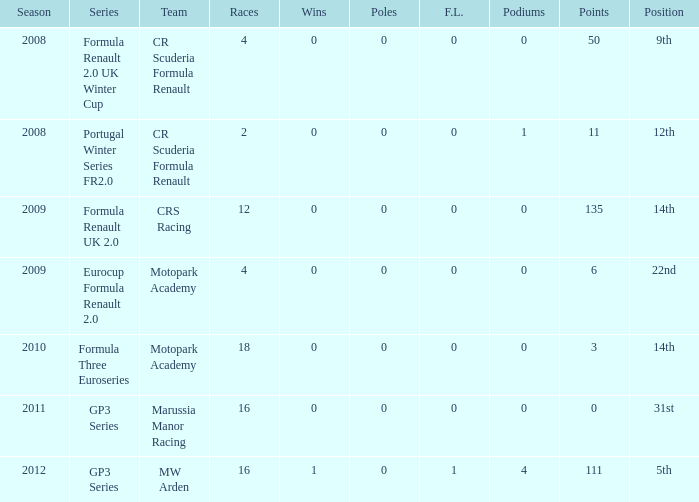How few podiums can there be at a minimum? 0.0. 